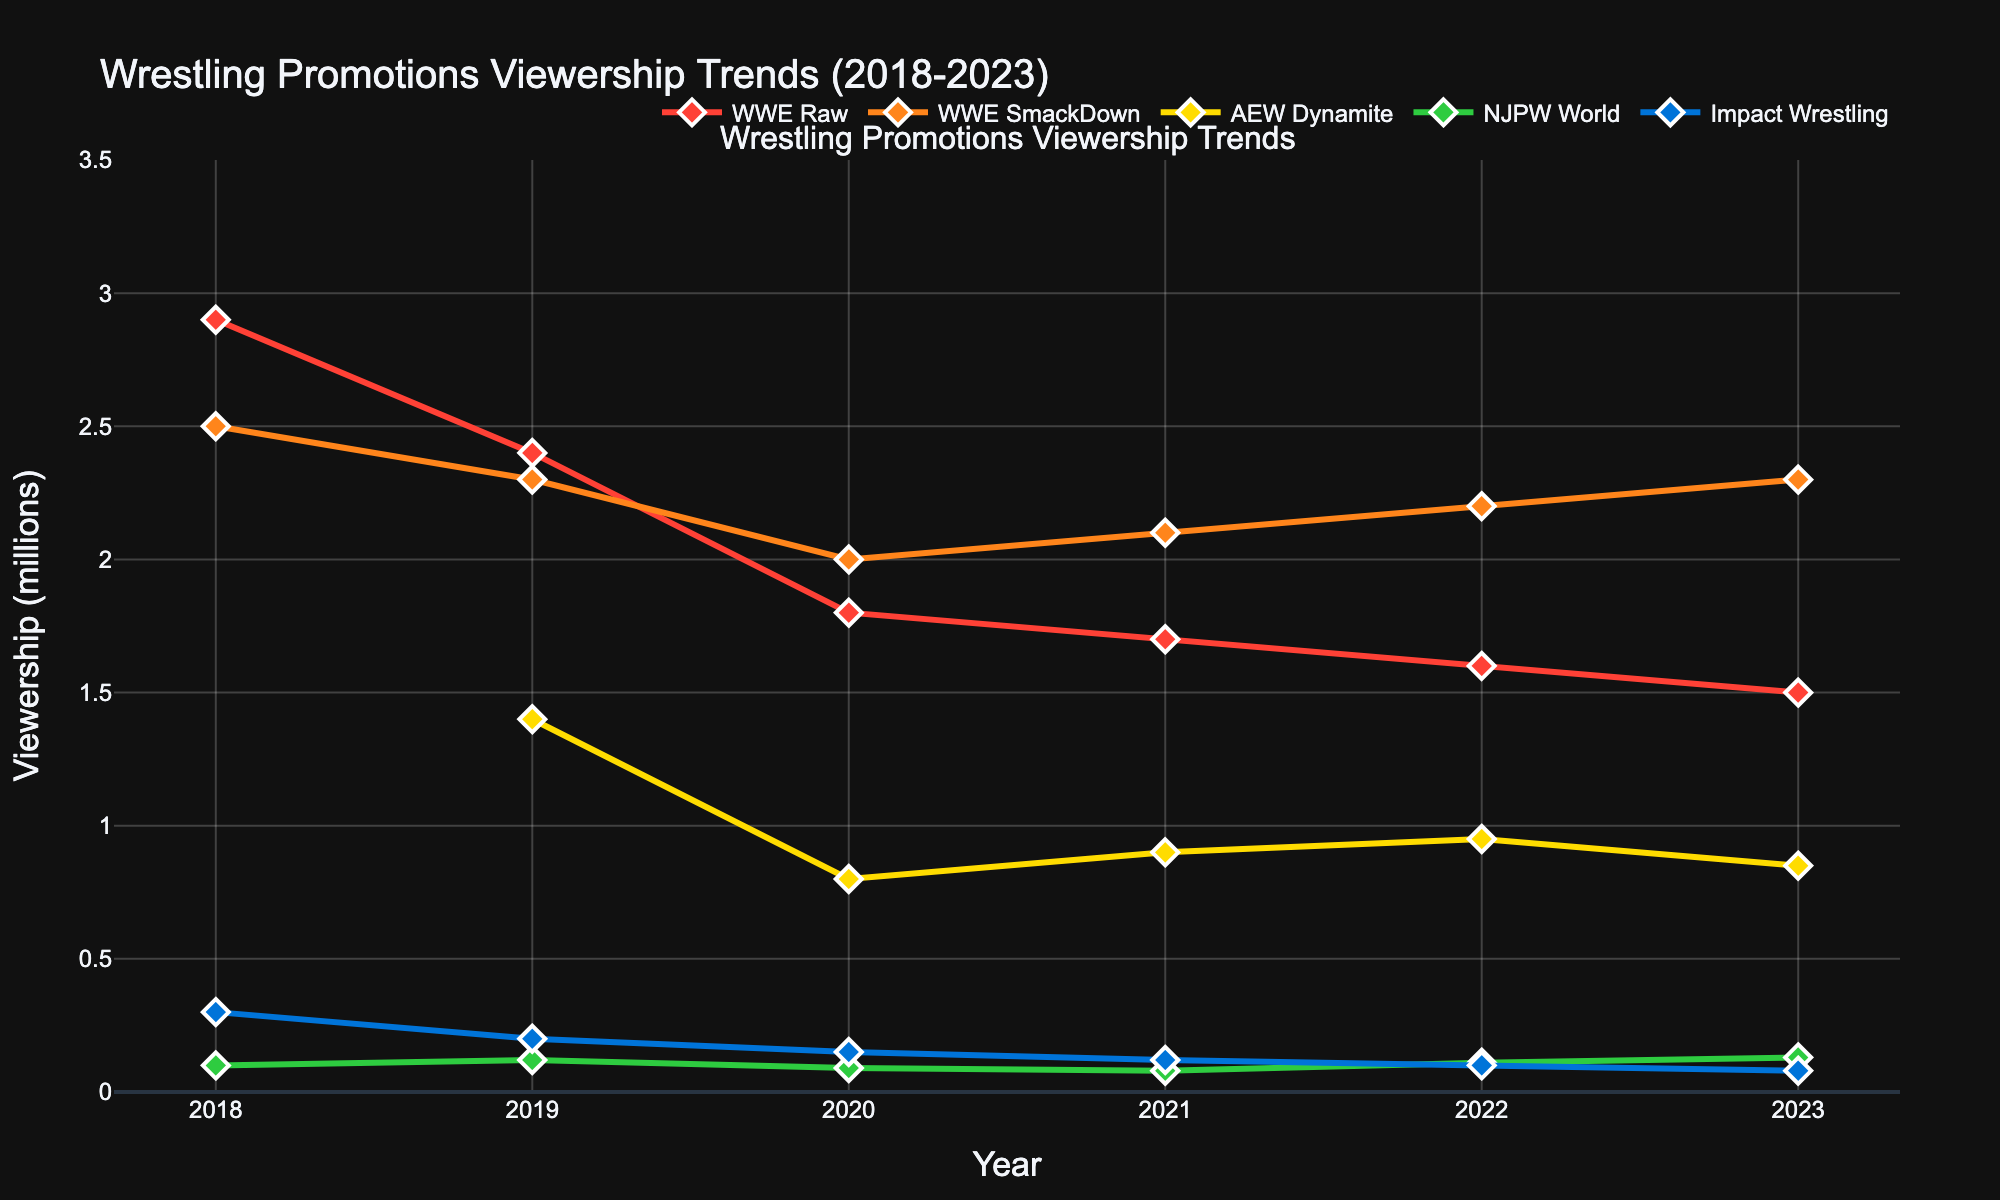What is the overall trend for WWE Raw's viewership from 2018 to 2023? WWE Raw's viewership decreases from 2.9 million in 2018 to 1.5 million in 2023. The numbers show a consistent decline over the years, indicating a steady downward trend.
Answer: Decreasing trend How does AEW Dynamite's viewership in 2023 compare to its debut year in 2019? AEW Dynamite's viewership was 1.4 million in 2019 and decreased to 0.85 million in 2023. So, it has dropped by 0.55 million over the years.
Answer: Decreased by 0.55 million Which wrestling promotion had the highest viewership in 2023? By observing the figure, WWE SmackDown had the highest viewership in 2023, reaching up to 2.3 million.
Answer: WWE SmackDown What is the difference in viewership between WWE Raw and WWE SmackDown in 2022? WWE Raw had 1.6 million viewers in 2022, while WWE SmackDown had 2.2 million. The difference is 2.2 million - 1.6 million = 0.6 million viewers.
Answer: 0.6 million viewers Between NJPW World and Impact Wrestling, which one showed more consistent viewership trends from 2018 to 2023? NJPW World showed a relatively steady trend ranging from 0.08 to 0.13 million, while Impact Wrestling had a more pronounced decline from 0.3 million to 0.08 million. Therefore, NJPW World had more consistent viewership.
Answer: NJPW World What is the average viewership of WWE SmackDown over the 5-year period? To calculate the average viewership of WWE SmackDown, sum up the viewership from 2018 to 2023 and then divide by the number of years: (2.5 + 2.3 + 2.0 + 2.1 + 2.2 + 2.3) / 6 = 2.23 million.
Answer: 2.23 million By how much did Impact Wrestling's viewership decline from 2018 to 2023? Impact Wrestling's viewership declined from 0.3 million in 2018 to 0.08 million in 2023. The decrease is 0.3 million - 0.08 million = 0.22 million.
Answer: 0.22 million Which promotion had the least viewership in 2020? NJPW World had the least viewership in 2020, with only 0.09 million viewers.
Answer: NJPW World How does the change in viewership for WWE SmackDown from 2022 to 2023 compare to that of WWE Raw in the same period? WWE SmackDown's viewership increased from 2.2 million in 2022 to 2.3 million in 2023, a difference of 0.1 million. WWE Raw's viewership decreased from 1.6 million in 2022 to 1.5 million in 2023, a difference of -0.1 million.
Answer: WWE SmackDown increased by 0.1 million, WWE Raw decreased by 0.1 million 